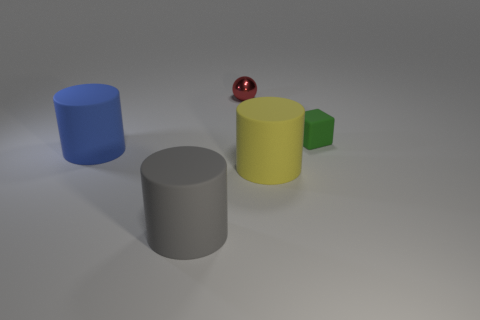Subtract all gray rubber cylinders. How many cylinders are left? 2 Add 5 big blue matte cylinders. How many objects exist? 10 Subtract 1 balls. How many balls are left? 0 Subtract all red balls. How many red cylinders are left? 0 Add 3 large objects. How many large objects are left? 6 Add 5 big yellow matte cubes. How many big yellow matte cubes exist? 5 Subtract 0 brown spheres. How many objects are left? 5 Subtract all cylinders. How many objects are left? 2 Subtract all purple cylinders. Subtract all cyan balls. How many cylinders are left? 3 Subtract all tiny yellow things. Subtract all gray rubber things. How many objects are left? 4 